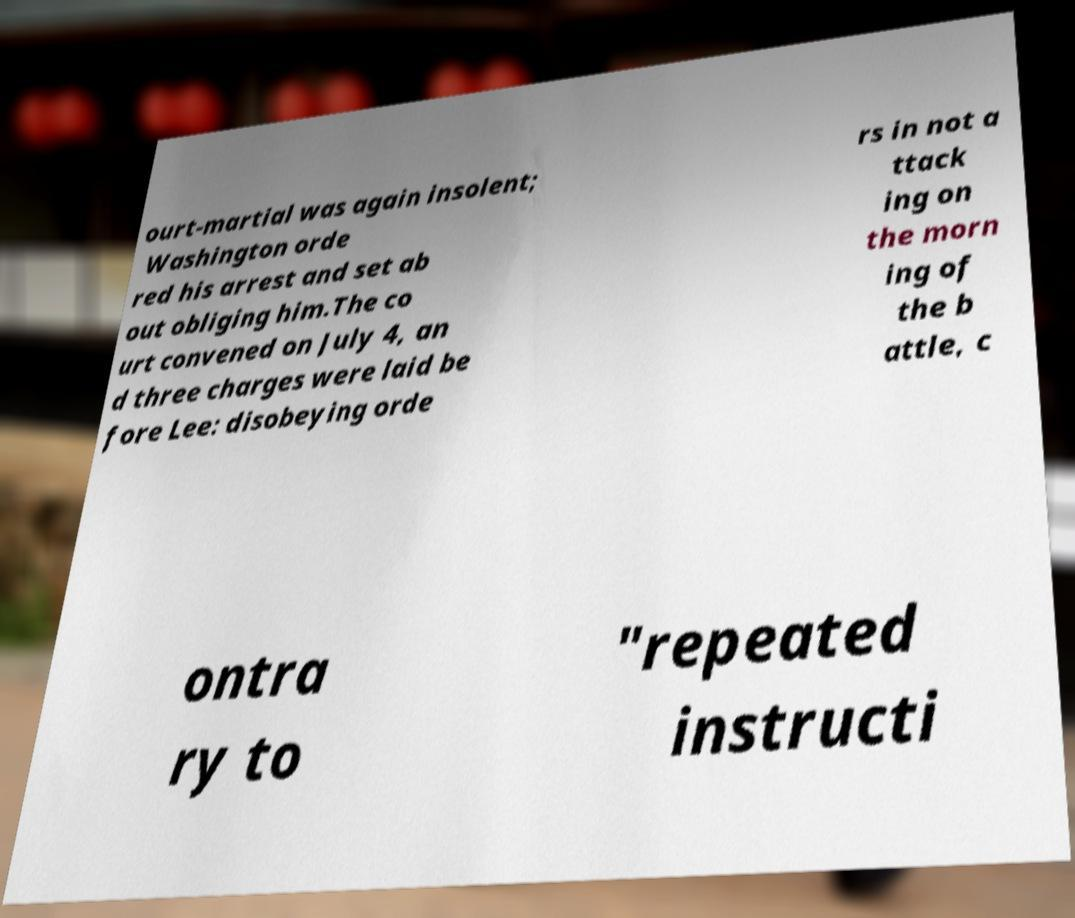I need the written content from this picture converted into text. Can you do that? ourt-martial was again insolent; Washington orde red his arrest and set ab out obliging him.The co urt convened on July 4, an d three charges were laid be fore Lee: disobeying orde rs in not a ttack ing on the morn ing of the b attle, c ontra ry to "repeated instructi 